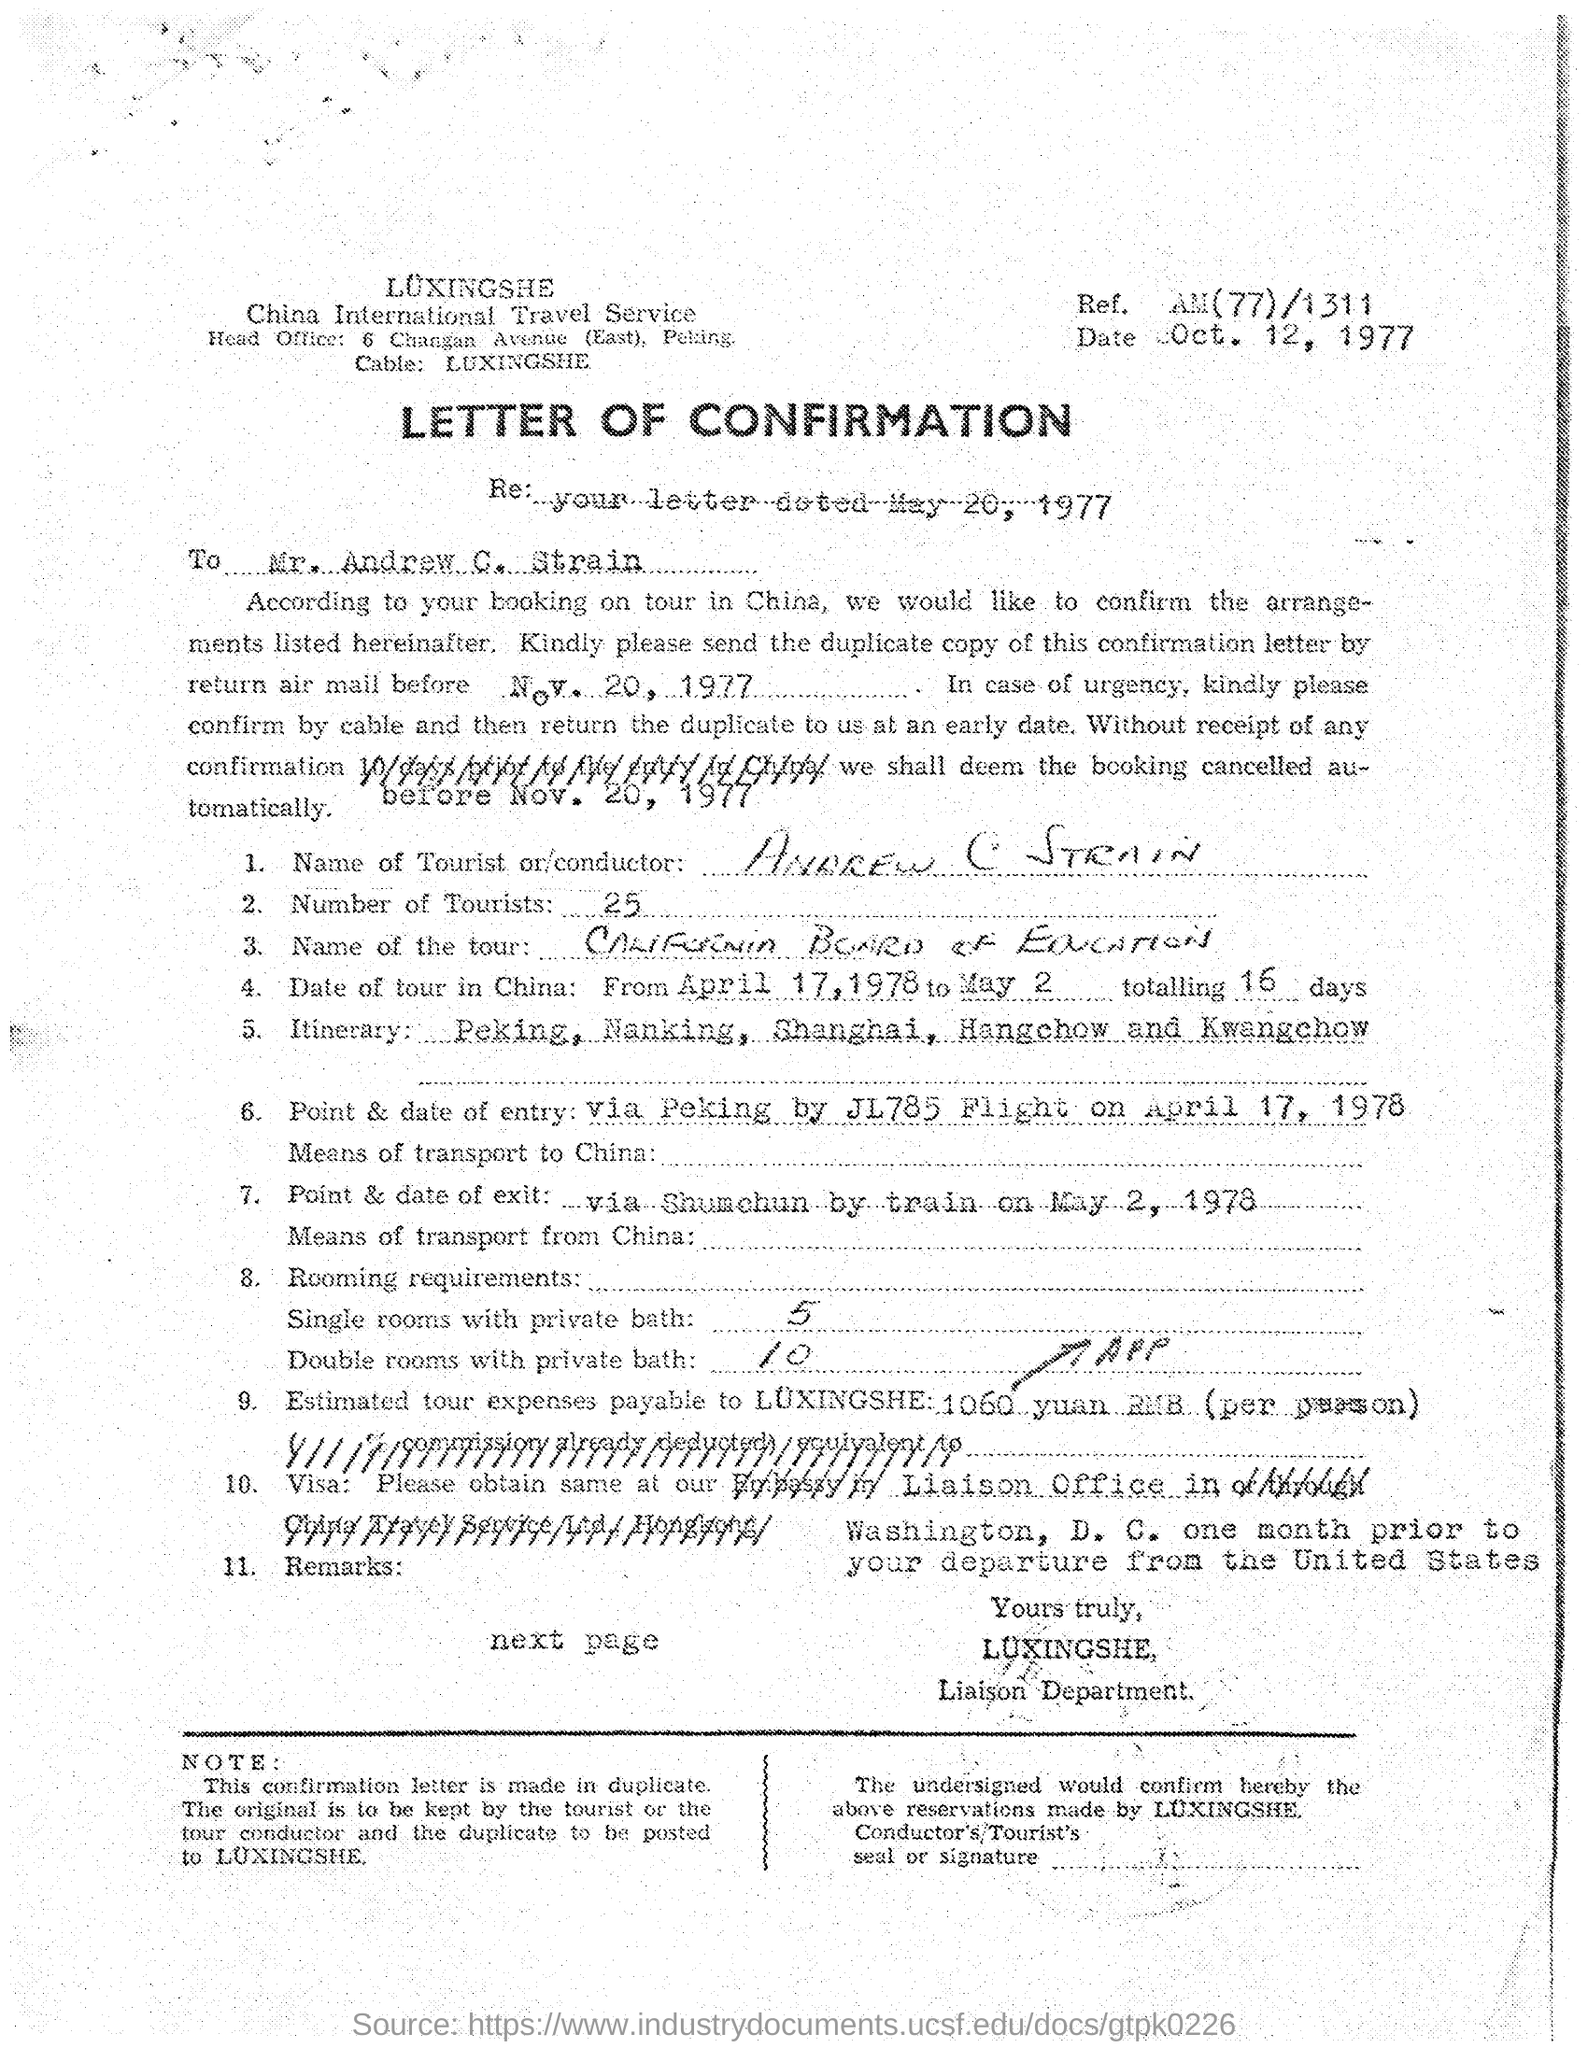Mention a couple of crucial points in this snapshot. Andrew C Strain is the tourist mentioned in the letter. According to the document, there were 25 tourists. Five single rooms with private baths are required, per the document. This document is a letter of confirmation. The Ref No mentioned on the letterhead is AM(77)/1311.. 